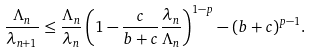Convert formula to latex. <formula><loc_0><loc_0><loc_500><loc_500>\frac { \Lambda _ { n } } { \lambda _ { n + 1 } } \leq \frac { \Lambda _ { n } } { \lambda _ { n } } \left ( 1 - \frac { c } { b + c } \frac { \lambda _ { n } } { \Lambda _ { n } } \right ) ^ { 1 - p } - ( b + c ) ^ { p - 1 } .</formula> 